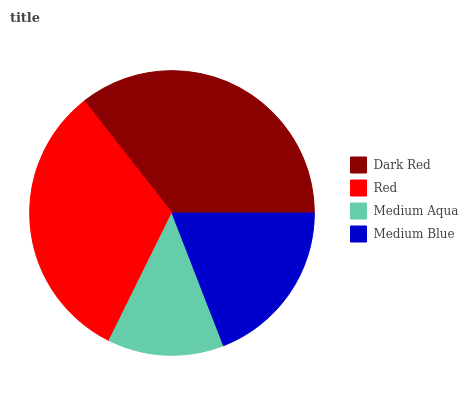Is Medium Aqua the minimum?
Answer yes or no. Yes. Is Dark Red the maximum?
Answer yes or no. Yes. Is Red the minimum?
Answer yes or no. No. Is Red the maximum?
Answer yes or no. No. Is Dark Red greater than Red?
Answer yes or no. Yes. Is Red less than Dark Red?
Answer yes or no. Yes. Is Red greater than Dark Red?
Answer yes or no. No. Is Dark Red less than Red?
Answer yes or no. No. Is Red the high median?
Answer yes or no. Yes. Is Medium Blue the low median?
Answer yes or no. Yes. Is Medium Blue the high median?
Answer yes or no. No. Is Medium Aqua the low median?
Answer yes or no. No. 